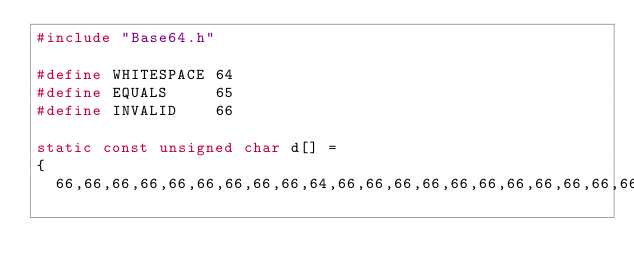Convert code to text. <code><loc_0><loc_0><loc_500><loc_500><_C_>#include "Base64.h"

#define WHITESPACE 64
#define EQUALS     65
#define INVALID    66

static const unsigned char d[] =
{
	66,66,66,66,66,66,66,66,66,64,66,66,66,66,66,66,66,66,66,66,66,66,66,66,66,</code> 